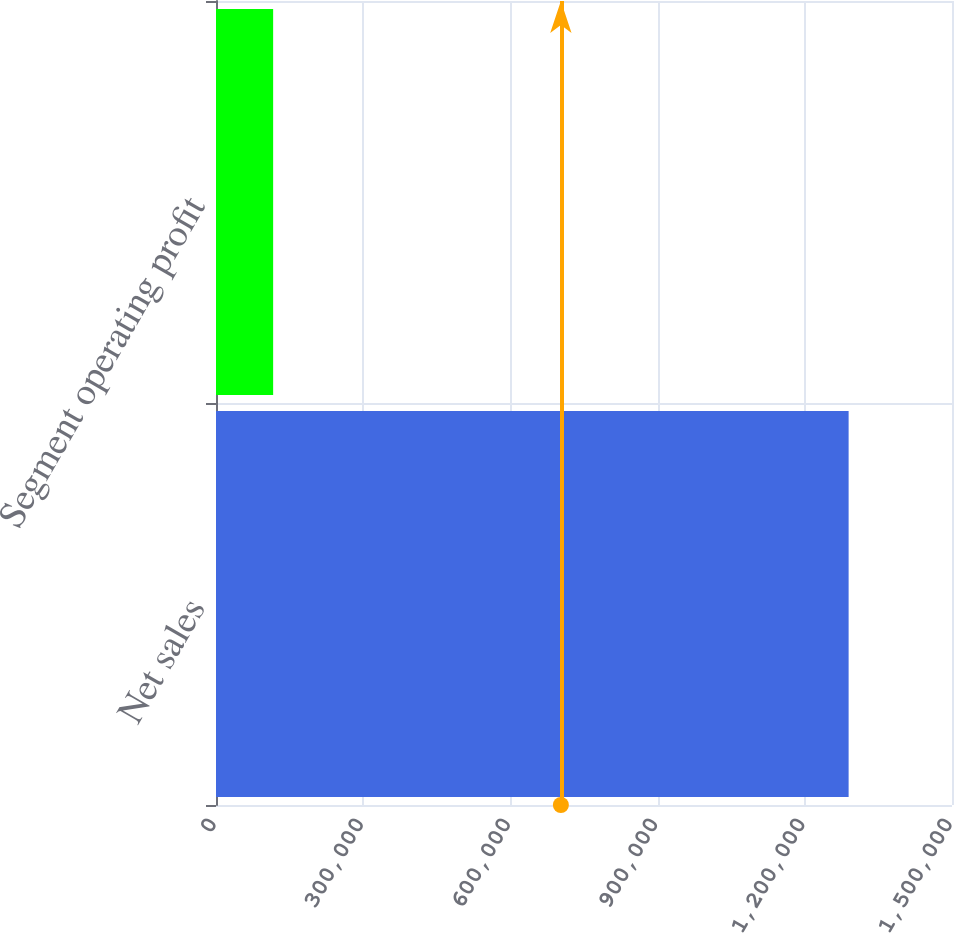<chart> <loc_0><loc_0><loc_500><loc_500><bar_chart><fcel>Net sales<fcel>Segment operating profit<nl><fcel>1.28931e+06<fcel>116457<nl></chart> 